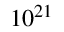<formula> <loc_0><loc_0><loc_500><loc_500>1 0 ^ { 2 1 }</formula> 